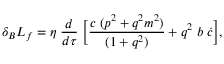Convert formula to latex. <formula><loc_0><loc_0><loc_500><loc_500>\delta _ { B } L _ { f } = \eta \, \frac { d } { d \tau } \, \left [ \frac { c \, ( p ^ { 2 } + q ^ { 2 } m ^ { 2 } ) } { ( 1 + q ^ { 2 } ) } + q ^ { 2 } \, b \, \dot { c } \right ] ,</formula> 